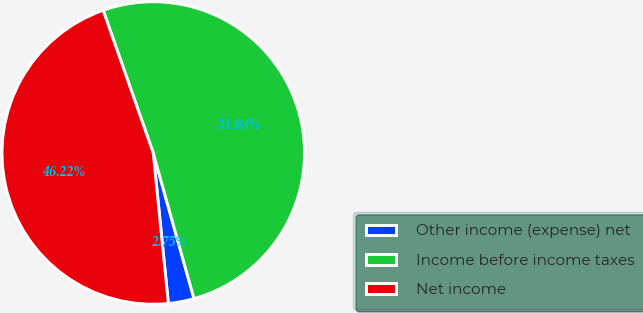<chart> <loc_0><loc_0><loc_500><loc_500><pie_chart><fcel>Other income (expense) net<fcel>Income before income taxes<fcel>Net income<nl><fcel>2.75%<fcel>51.03%<fcel>46.22%<nl></chart> 